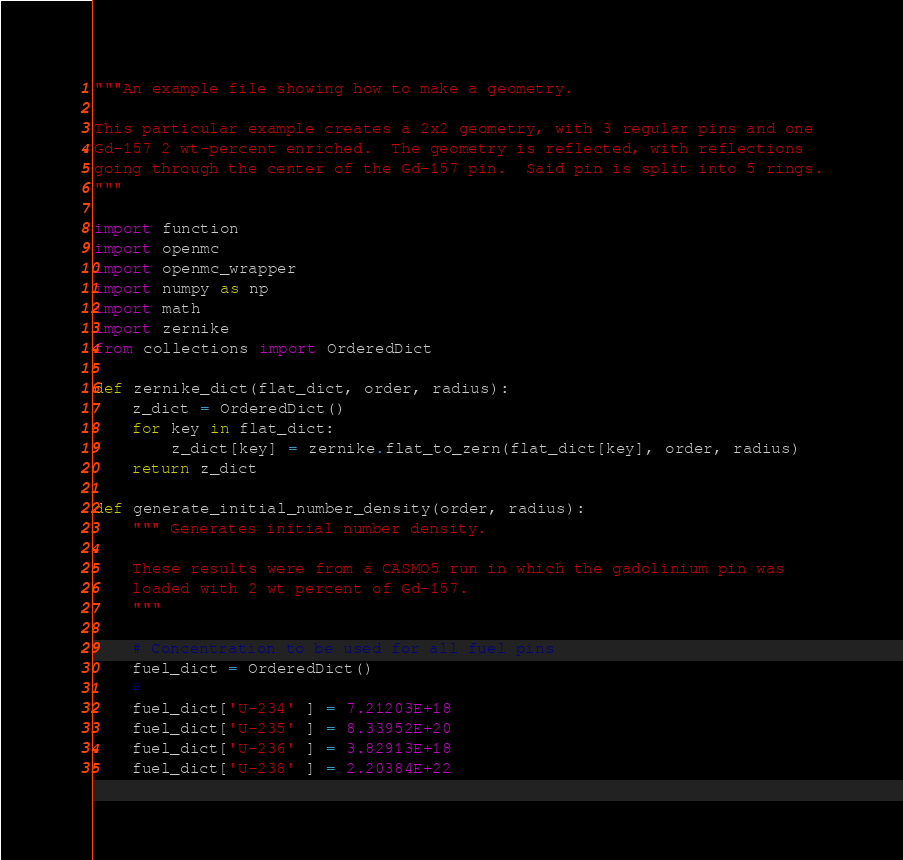Convert code to text. <code><loc_0><loc_0><loc_500><loc_500><_Python_>"""An example file showing how to make a geometry.

This particular example creates a 2x2 geometry, with 3 regular pins and one
Gd-157 2 wt-percent enriched.  The geometry is reflected, with reflections
going through the center of the Gd-157 pin.  Said pin is split into 5 rings.
"""

import function
import openmc
import openmc_wrapper
import numpy as np
import math
import zernike
from collections import OrderedDict

def zernike_dict(flat_dict, order, radius):
    z_dict = OrderedDict()
    for key in flat_dict:
        z_dict[key] = zernike.flat_to_zern(flat_dict[key], order, radius)
    return z_dict

def generate_initial_number_density(order, radius):
    """ Generates initial number density.

    These results were from a CASMO5 run in which the gadolinium pin was
    loaded with 2 wt percent of Gd-157.
    """

    # Concentration to be used for all fuel pins
    fuel_dict = OrderedDict()
    #
    fuel_dict['U-234' ] = 7.21203E+18
    fuel_dict['U-235' ] = 8.33952E+20
    fuel_dict['U-236' ] = 3.82913E+18
    fuel_dict['U-238' ] = 2.20384E+22</code> 